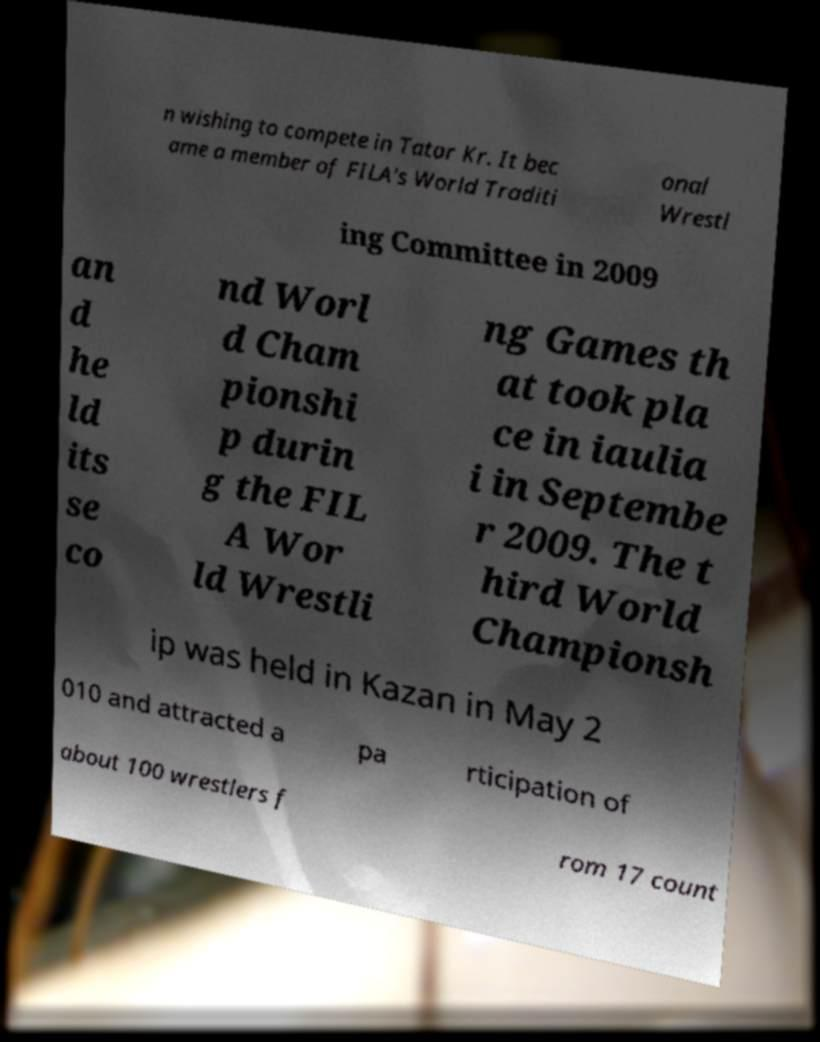Please identify and transcribe the text found in this image. n wishing to compete in Tatar Kr. It bec ame a member of FILA's World Traditi onal Wrestl ing Committee in 2009 an d he ld its se co nd Worl d Cham pionshi p durin g the FIL A Wor ld Wrestli ng Games th at took pla ce in iaulia i in Septembe r 2009. The t hird World Championsh ip was held in Kazan in May 2 010 and attracted a pa rticipation of about 100 wrestlers f rom 17 count 